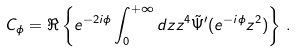<formula> <loc_0><loc_0><loc_500><loc_500>C _ { \phi } = \Re \left \{ e ^ { - 2 i \phi } \int _ { 0 } ^ { + \infty } d z z ^ { 4 } \tilde { \Psi } ^ { \prime } ( e ^ { - i \phi } z ^ { 2 } ) \right \} \, .</formula> 